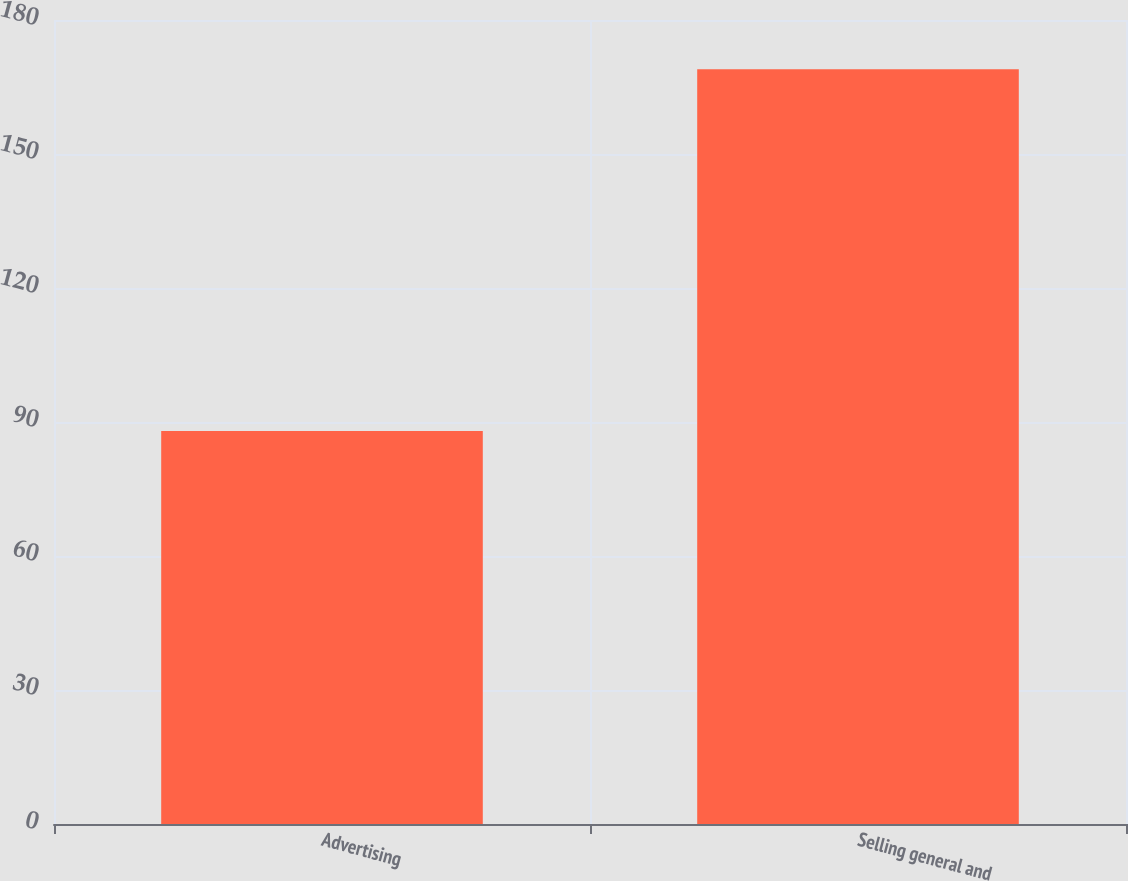Convert chart. <chart><loc_0><loc_0><loc_500><loc_500><bar_chart><fcel>Advertising<fcel>Selling general and<nl><fcel>88<fcel>169<nl></chart> 